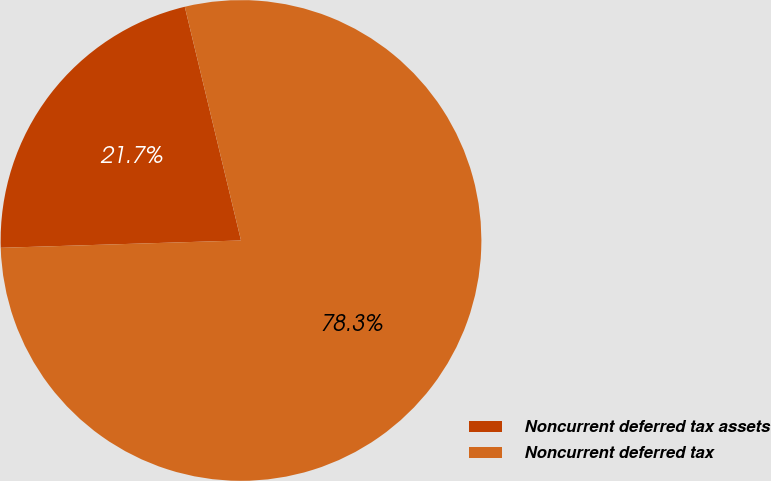<chart> <loc_0><loc_0><loc_500><loc_500><pie_chart><fcel>Noncurrent deferred tax assets<fcel>Noncurrent deferred tax<nl><fcel>21.73%<fcel>78.27%<nl></chart> 